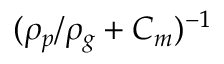Convert formula to latex. <formula><loc_0><loc_0><loc_500><loc_500>( \rho _ { p } / \rho _ { g } + C _ { m } ) ^ { - 1 }</formula> 